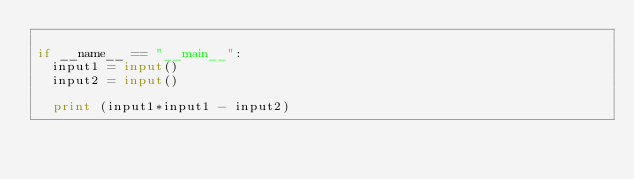Convert code to text. <code><loc_0><loc_0><loc_500><loc_500><_Python_>
if __name__ == "__main__":
  input1 = input()
  input2 = input()

  print (input1*input1 - input2)

</code> 